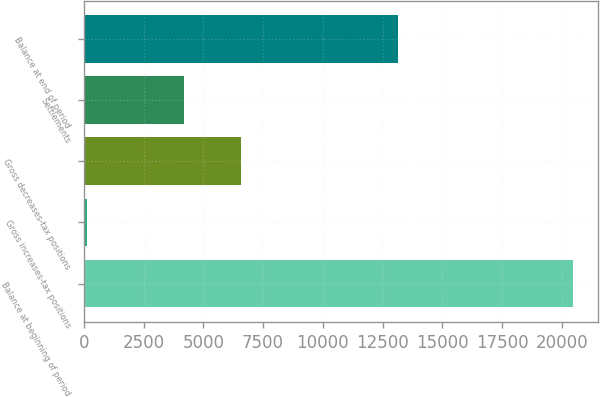<chart> <loc_0><loc_0><loc_500><loc_500><bar_chart><fcel>Balance at beginning of period<fcel>Gross increases-tax positions<fcel>Gross decreases-tax positions<fcel>Settlements<fcel>Balance at end of period<nl><fcel>20485<fcel>130<fcel>6592<fcel>4201<fcel>13135<nl></chart> 